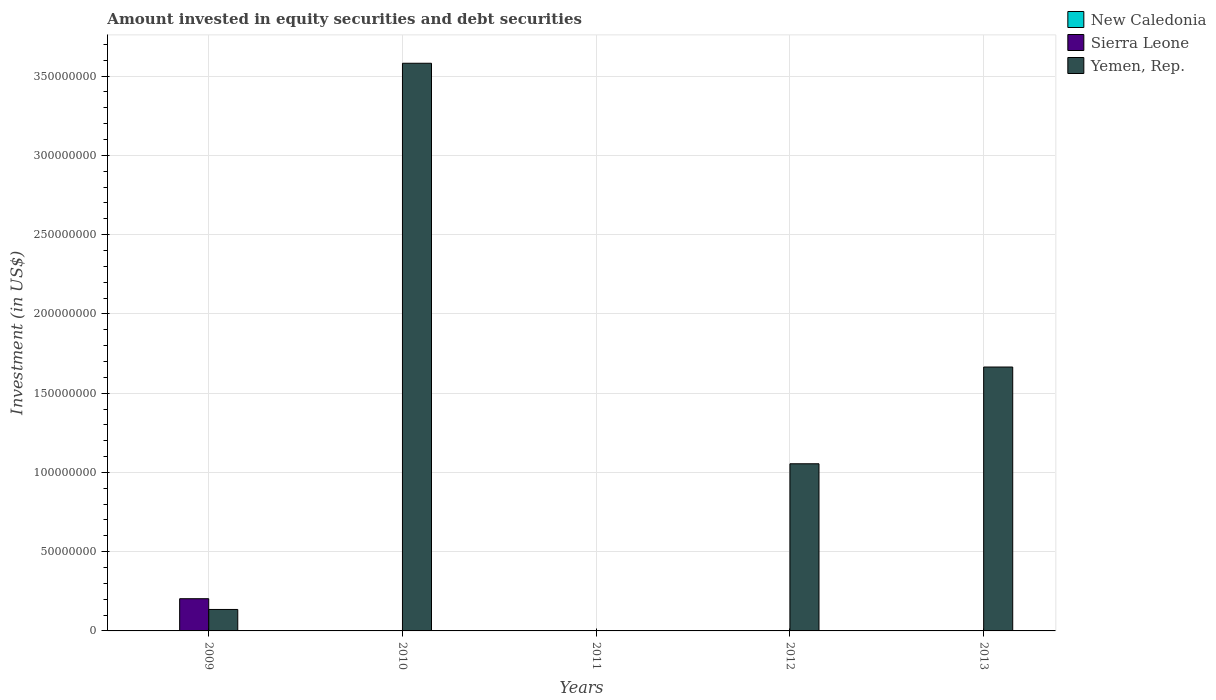How many different coloured bars are there?
Provide a short and direct response. 2. Are the number of bars per tick equal to the number of legend labels?
Ensure brevity in your answer.  No. Are the number of bars on each tick of the X-axis equal?
Provide a short and direct response. No. How many bars are there on the 4th tick from the right?
Your answer should be compact. 1. What is the label of the 1st group of bars from the left?
Provide a succinct answer. 2009. In how many cases, is the number of bars for a given year not equal to the number of legend labels?
Provide a succinct answer. 5. What is the amount invested in equity securities and debt securities in Yemen, Rep. in 2013?
Offer a terse response. 1.66e+08. Across all years, what is the maximum amount invested in equity securities and debt securities in Sierra Leone?
Your response must be concise. 2.03e+07. In which year was the amount invested in equity securities and debt securities in Yemen, Rep. maximum?
Offer a very short reply. 2010. What is the total amount invested in equity securities and debt securities in Sierra Leone in the graph?
Provide a short and direct response. 2.03e+07. What is the difference between the amount invested in equity securities and debt securities in Yemen, Rep. in 2012 and that in 2013?
Provide a short and direct response. -6.10e+07. What is the difference between the amount invested in equity securities and debt securities in New Caledonia in 2009 and the amount invested in equity securities and debt securities in Yemen, Rep. in 2013?
Your answer should be very brief. -1.66e+08. What is the average amount invested in equity securities and debt securities in Yemen, Rep. per year?
Provide a succinct answer. 1.29e+08. In the year 2009, what is the difference between the amount invested in equity securities and debt securities in Yemen, Rep. and amount invested in equity securities and debt securities in Sierra Leone?
Keep it short and to the point. -6.79e+06. What is the ratio of the amount invested in equity securities and debt securities in Yemen, Rep. in 2009 to that in 2013?
Offer a terse response. 0.08. What is the difference between the highest and the second highest amount invested in equity securities and debt securities in Yemen, Rep.?
Provide a succinct answer. 1.92e+08. What is the difference between the highest and the lowest amount invested in equity securities and debt securities in Sierra Leone?
Your answer should be compact. 2.03e+07. How many bars are there?
Your answer should be compact. 5. Does the graph contain any zero values?
Keep it short and to the point. Yes. Does the graph contain grids?
Keep it short and to the point. Yes. Where does the legend appear in the graph?
Give a very brief answer. Top right. How many legend labels are there?
Offer a very short reply. 3. What is the title of the graph?
Offer a terse response. Amount invested in equity securities and debt securities. Does "Channel Islands" appear as one of the legend labels in the graph?
Your response must be concise. No. What is the label or title of the X-axis?
Provide a short and direct response. Years. What is the label or title of the Y-axis?
Keep it short and to the point. Investment (in US$). What is the Investment (in US$) in New Caledonia in 2009?
Offer a very short reply. 0. What is the Investment (in US$) in Sierra Leone in 2009?
Your response must be concise. 2.03e+07. What is the Investment (in US$) of Yemen, Rep. in 2009?
Provide a succinct answer. 1.35e+07. What is the Investment (in US$) in Sierra Leone in 2010?
Make the answer very short. 0. What is the Investment (in US$) in Yemen, Rep. in 2010?
Make the answer very short. 3.58e+08. What is the Investment (in US$) of Yemen, Rep. in 2011?
Keep it short and to the point. 0. What is the Investment (in US$) of Sierra Leone in 2012?
Provide a succinct answer. 0. What is the Investment (in US$) of Yemen, Rep. in 2012?
Your answer should be very brief. 1.05e+08. What is the Investment (in US$) in New Caledonia in 2013?
Your response must be concise. 0. What is the Investment (in US$) of Yemen, Rep. in 2013?
Offer a terse response. 1.66e+08. Across all years, what is the maximum Investment (in US$) of Sierra Leone?
Offer a terse response. 2.03e+07. Across all years, what is the maximum Investment (in US$) of Yemen, Rep.?
Provide a succinct answer. 3.58e+08. Across all years, what is the minimum Investment (in US$) in Yemen, Rep.?
Keep it short and to the point. 0. What is the total Investment (in US$) of New Caledonia in the graph?
Your response must be concise. 0. What is the total Investment (in US$) of Sierra Leone in the graph?
Make the answer very short. 2.03e+07. What is the total Investment (in US$) in Yemen, Rep. in the graph?
Make the answer very short. 6.44e+08. What is the difference between the Investment (in US$) in Yemen, Rep. in 2009 and that in 2010?
Give a very brief answer. -3.45e+08. What is the difference between the Investment (in US$) in Yemen, Rep. in 2009 and that in 2012?
Offer a terse response. -9.19e+07. What is the difference between the Investment (in US$) of Yemen, Rep. in 2009 and that in 2013?
Provide a short and direct response. -1.53e+08. What is the difference between the Investment (in US$) in Yemen, Rep. in 2010 and that in 2012?
Provide a succinct answer. 2.53e+08. What is the difference between the Investment (in US$) in Yemen, Rep. in 2010 and that in 2013?
Give a very brief answer. 1.92e+08. What is the difference between the Investment (in US$) in Yemen, Rep. in 2012 and that in 2013?
Provide a succinct answer. -6.10e+07. What is the difference between the Investment (in US$) of Sierra Leone in 2009 and the Investment (in US$) of Yemen, Rep. in 2010?
Give a very brief answer. -3.38e+08. What is the difference between the Investment (in US$) in Sierra Leone in 2009 and the Investment (in US$) in Yemen, Rep. in 2012?
Make the answer very short. -8.51e+07. What is the difference between the Investment (in US$) of Sierra Leone in 2009 and the Investment (in US$) of Yemen, Rep. in 2013?
Make the answer very short. -1.46e+08. What is the average Investment (in US$) of Sierra Leone per year?
Give a very brief answer. 4.07e+06. What is the average Investment (in US$) of Yemen, Rep. per year?
Your answer should be compact. 1.29e+08. In the year 2009, what is the difference between the Investment (in US$) of Sierra Leone and Investment (in US$) of Yemen, Rep.?
Keep it short and to the point. 6.79e+06. What is the ratio of the Investment (in US$) of Yemen, Rep. in 2009 to that in 2010?
Offer a terse response. 0.04. What is the ratio of the Investment (in US$) in Yemen, Rep. in 2009 to that in 2012?
Offer a terse response. 0.13. What is the ratio of the Investment (in US$) in Yemen, Rep. in 2009 to that in 2013?
Make the answer very short. 0.08. What is the ratio of the Investment (in US$) of Yemen, Rep. in 2010 to that in 2012?
Give a very brief answer. 3.4. What is the ratio of the Investment (in US$) of Yemen, Rep. in 2010 to that in 2013?
Offer a very short reply. 2.15. What is the ratio of the Investment (in US$) of Yemen, Rep. in 2012 to that in 2013?
Make the answer very short. 0.63. What is the difference between the highest and the second highest Investment (in US$) in Yemen, Rep.?
Offer a terse response. 1.92e+08. What is the difference between the highest and the lowest Investment (in US$) of Sierra Leone?
Give a very brief answer. 2.03e+07. What is the difference between the highest and the lowest Investment (in US$) of Yemen, Rep.?
Give a very brief answer. 3.58e+08. 